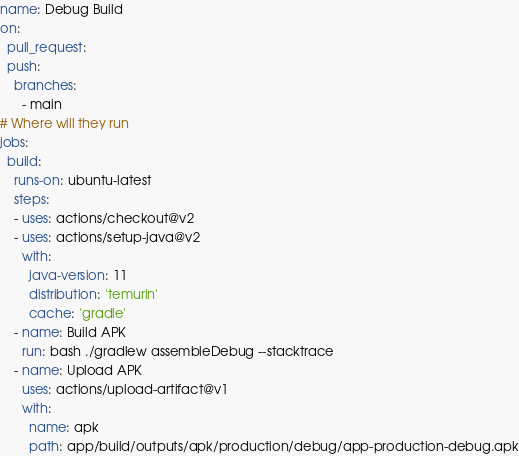<code> <loc_0><loc_0><loc_500><loc_500><_YAML_>name: Debug Build
on:
  pull_request:
  push:
    branches:
      - main
# Where will they run
jobs:
  build:
    runs-on: ubuntu-latest
    steps:
    - uses: actions/checkout@v2
    - uses: actions/setup-java@v2
      with:
        java-version: 11
        distribution: 'temurin'
        cache: 'gradle'
    - name: Build APK
      run: bash ./gradlew assembleDebug --stacktrace
    - name: Upload APK
      uses: actions/upload-artifact@v1
      with:
        name: apk
        path: app/build/outputs/apk/production/debug/app-production-debug.apk
</code> 